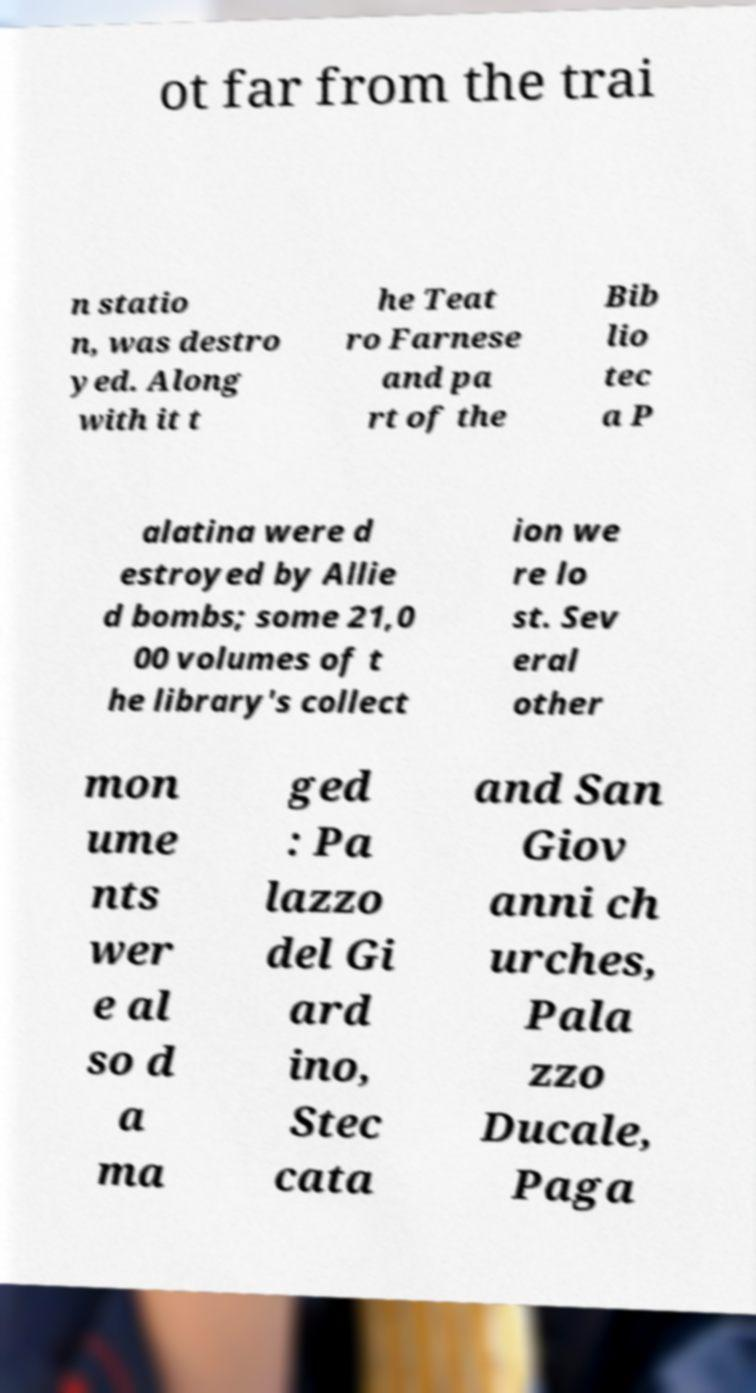For documentation purposes, I need the text within this image transcribed. Could you provide that? ot far from the trai n statio n, was destro yed. Along with it t he Teat ro Farnese and pa rt of the Bib lio tec a P alatina were d estroyed by Allie d bombs; some 21,0 00 volumes of t he library's collect ion we re lo st. Sev eral other mon ume nts wer e al so d a ma ged : Pa lazzo del Gi ard ino, Stec cata and San Giov anni ch urches, Pala zzo Ducale, Paga 